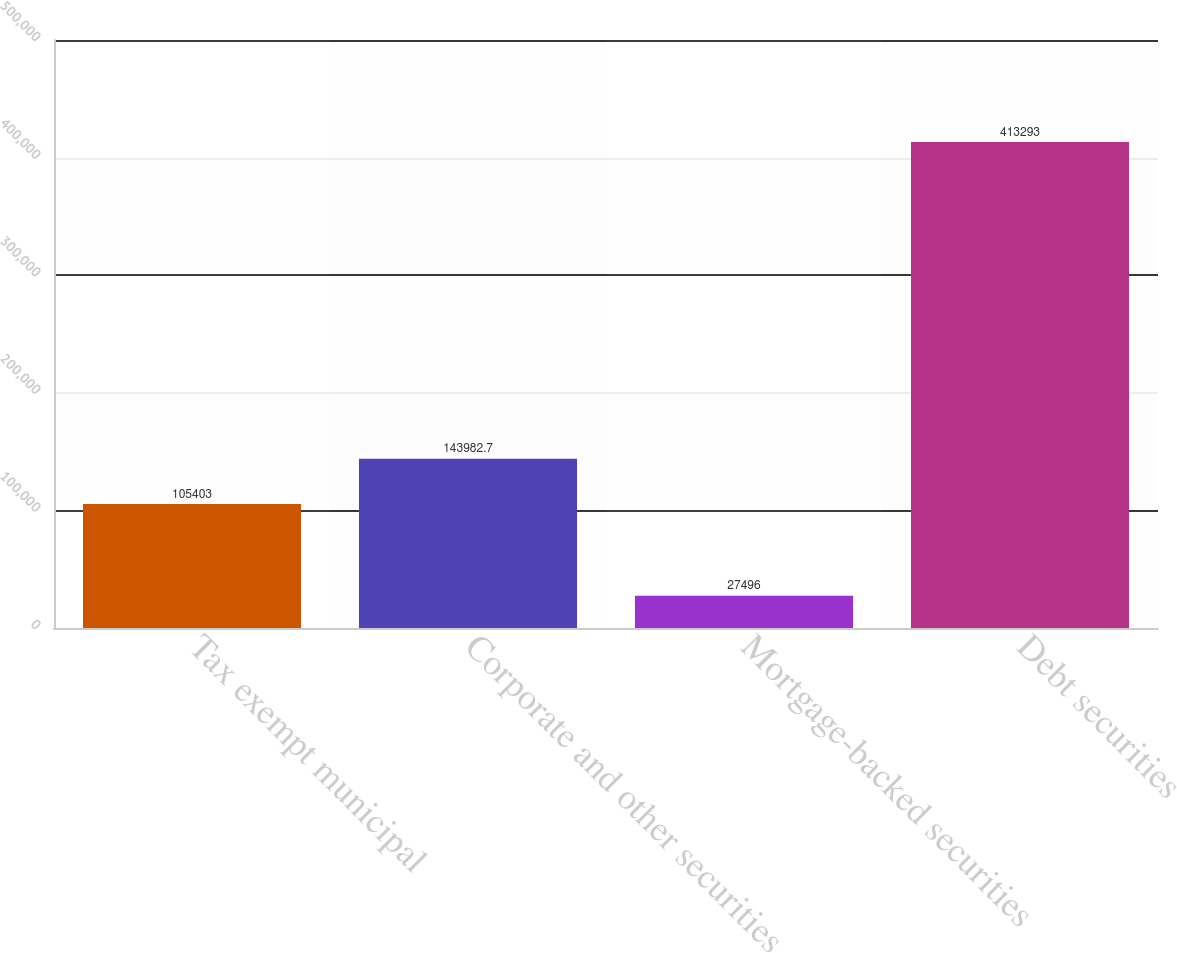Convert chart. <chart><loc_0><loc_0><loc_500><loc_500><bar_chart><fcel>Tax exempt municipal<fcel>Corporate and other securities<fcel>Mortgage-backed securities<fcel>Debt securities<nl><fcel>105403<fcel>143983<fcel>27496<fcel>413293<nl></chart> 